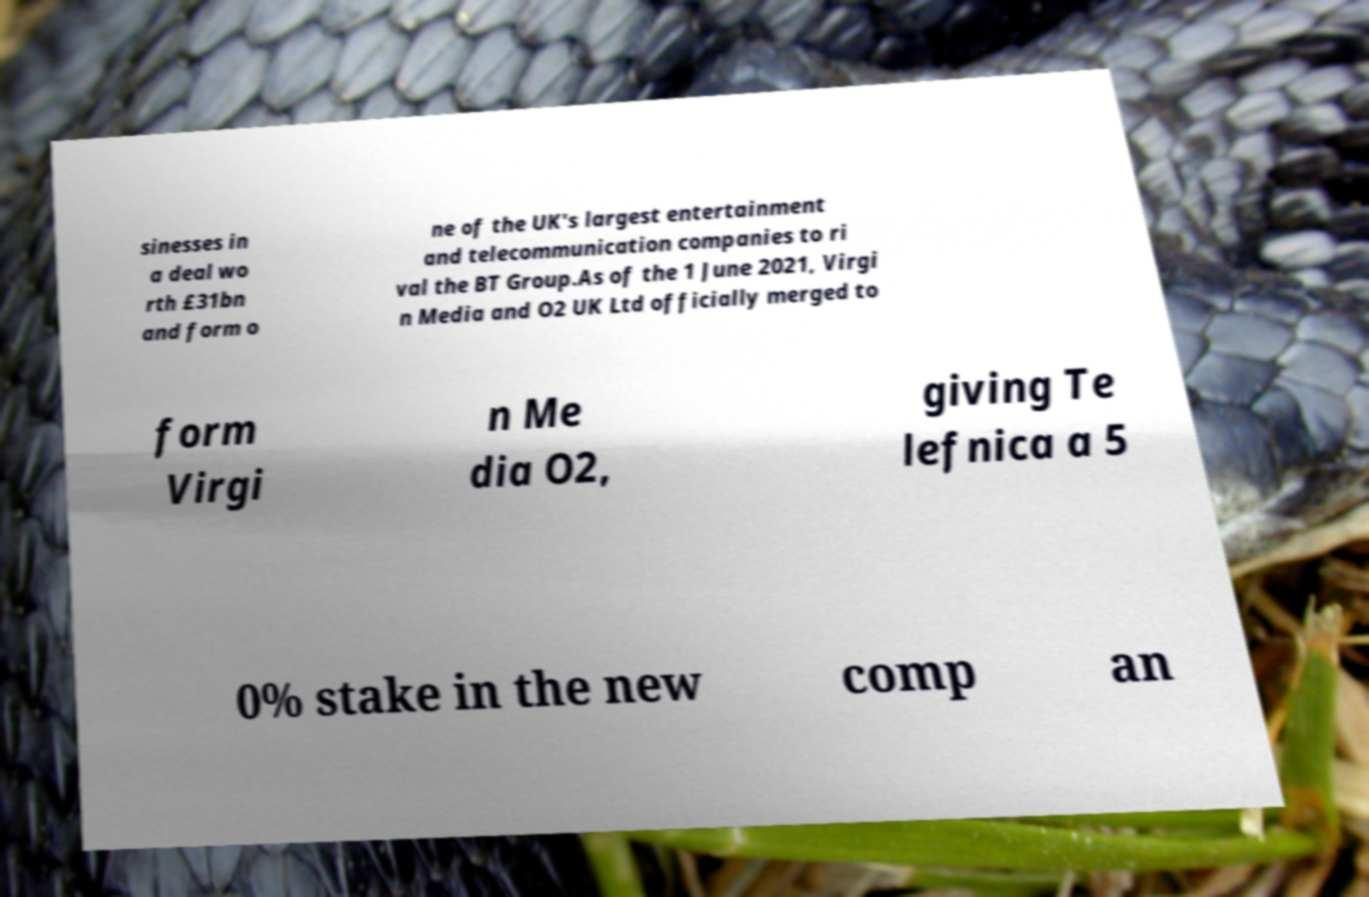Please read and relay the text visible in this image. What does it say? sinesses in a deal wo rth £31bn and form o ne of the UK's largest entertainment and telecommunication companies to ri val the BT Group.As of the 1 June 2021, Virgi n Media and O2 UK Ltd officially merged to form Virgi n Me dia O2, giving Te lefnica a 5 0% stake in the new comp an 